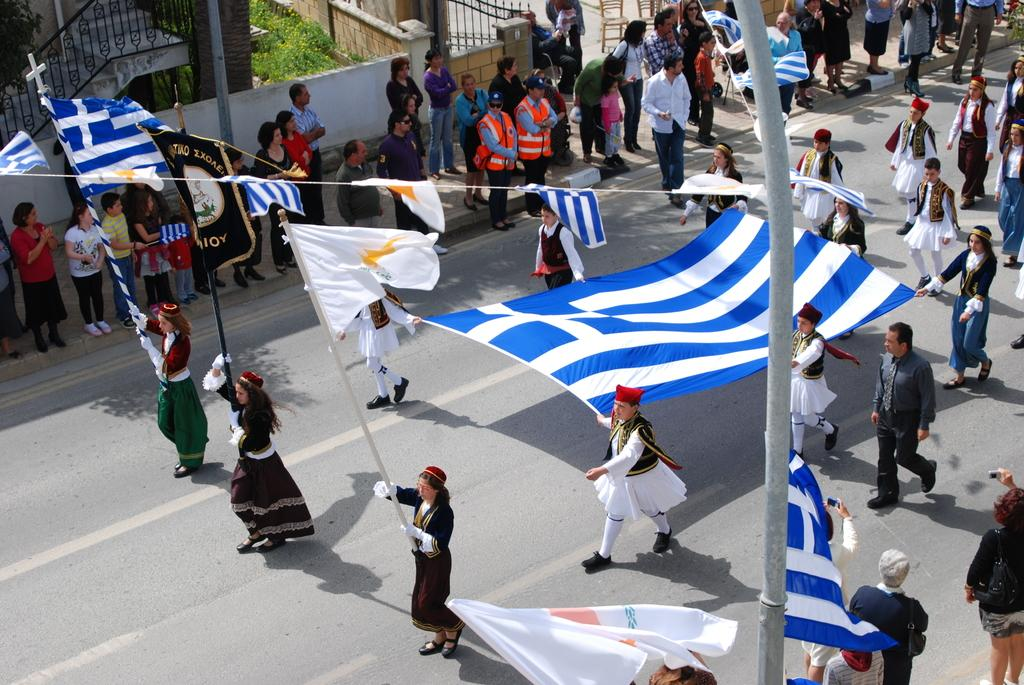Who or what is present in the image? There are people in the image. What are the people holding in the image? The people are holding a flag. What architectural feature can be seen in the image? There are stairs visible in the image. What structure is present in the image? There is a gate in the image. What type of furniture is in the image? There are chairs in the image. What type of patch can be seen on the flag in the image? There is no patch visible on the flag in the image. 